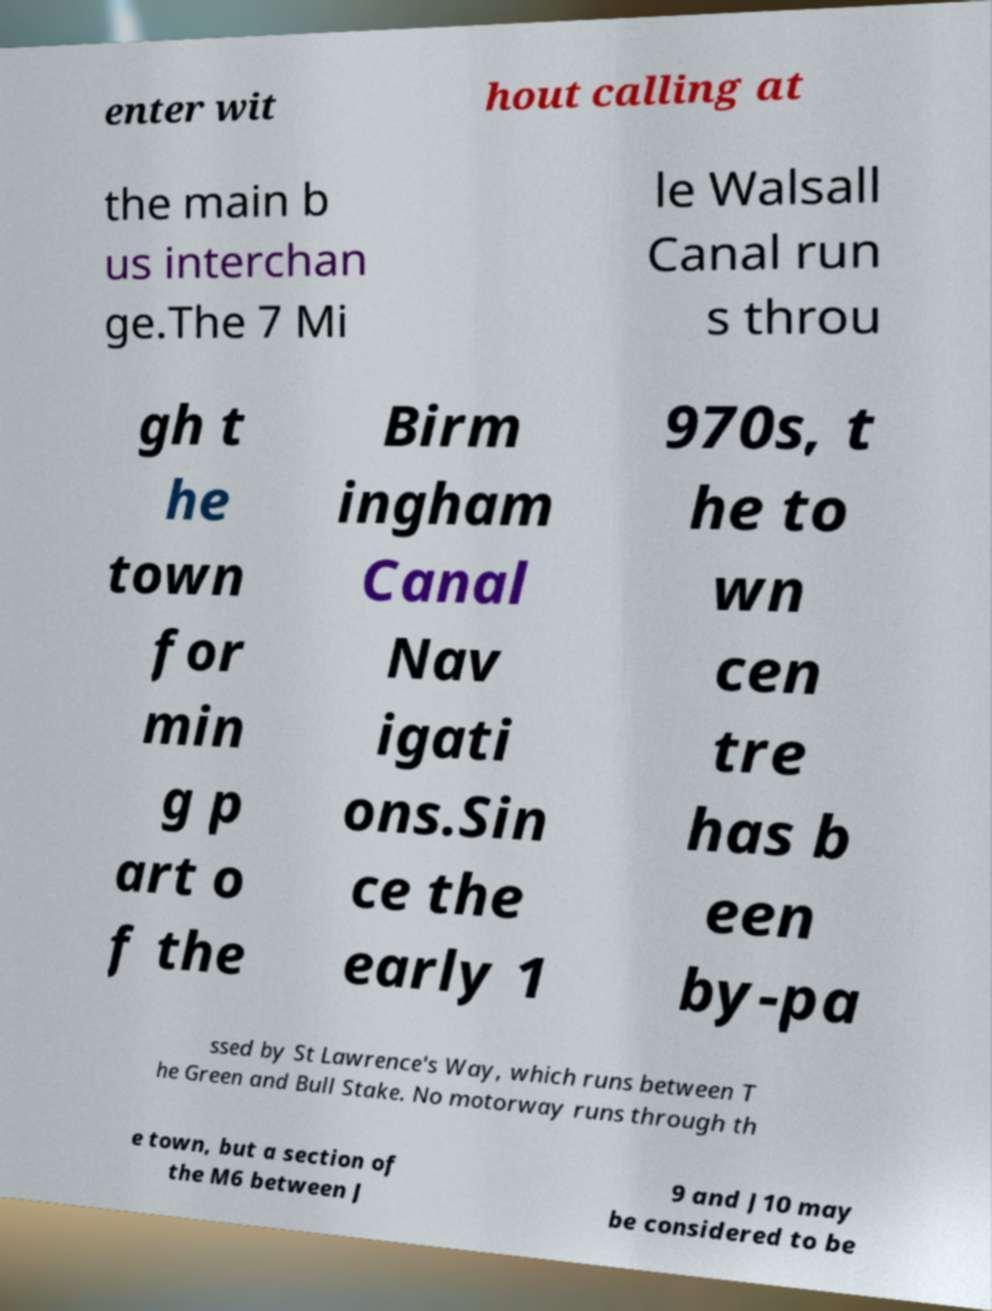Please read and relay the text visible in this image. What does it say? enter wit hout calling at the main b us interchan ge.The 7 Mi le Walsall Canal run s throu gh t he town for min g p art o f the Birm ingham Canal Nav igati ons.Sin ce the early 1 970s, t he to wn cen tre has b een by-pa ssed by St Lawrence's Way, which runs between T he Green and Bull Stake. No motorway runs through th e town, but a section of the M6 between J 9 and J10 may be considered to be 